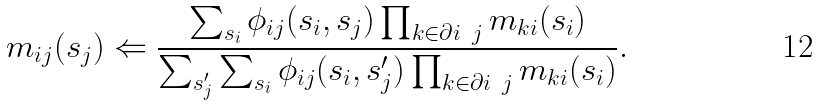Convert formula to latex. <formula><loc_0><loc_0><loc_500><loc_500>& m _ { i j } ( s _ { j } ) \Leftarrow \frac { \sum _ { s _ { i } } \phi _ { i j } ( s _ { i } , s _ { j } ) \prod _ { k \in \partial i \ j } m _ { k i } ( s _ { i } ) } { \sum _ { s _ { j } ^ { \prime } } \sum _ { s _ { i } } \phi _ { i j } ( s _ { i } , s _ { j } ^ { \prime } ) \prod _ { k \in \partial i \ j } m _ { k i } ( s _ { i } ) } .</formula> 